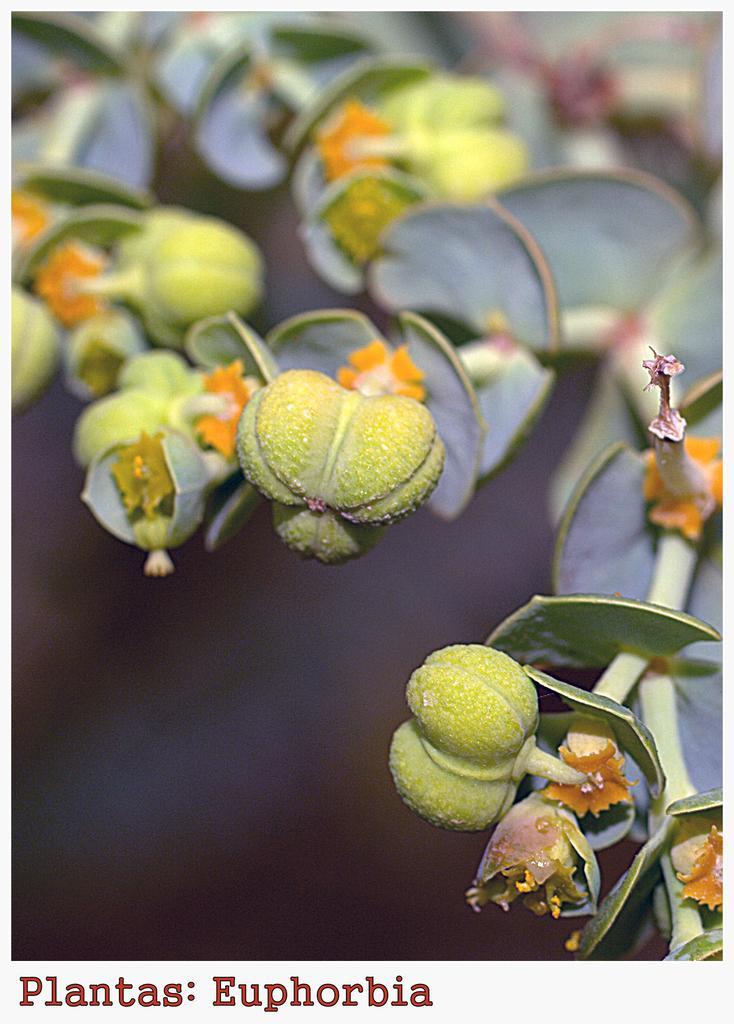Please provide a concise description of this image. In this image there are flowers on the stem. 